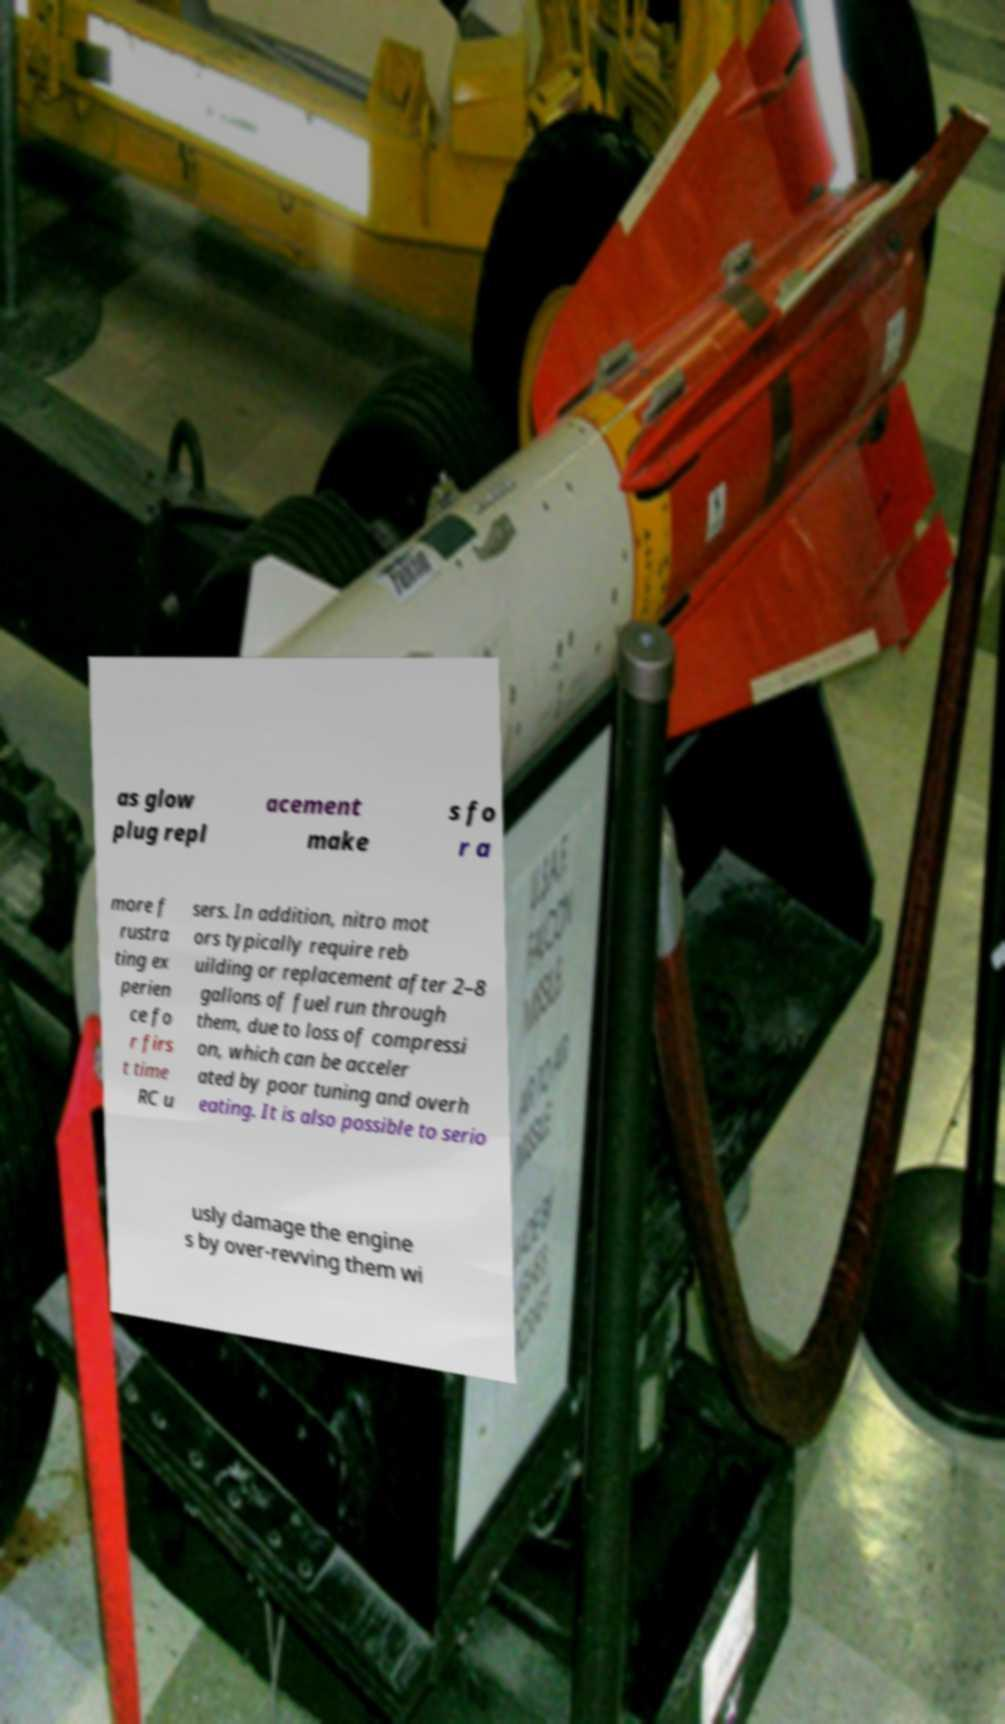Can you read and provide the text displayed in the image?This photo seems to have some interesting text. Can you extract and type it out for me? as glow plug repl acement make s fo r a more f rustra ting ex perien ce fo r firs t time RC u sers. In addition, nitro mot ors typically require reb uilding or replacement after 2–8 gallons of fuel run through them, due to loss of compressi on, which can be acceler ated by poor tuning and overh eating. It is also possible to serio usly damage the engine s by over-revving them wi 